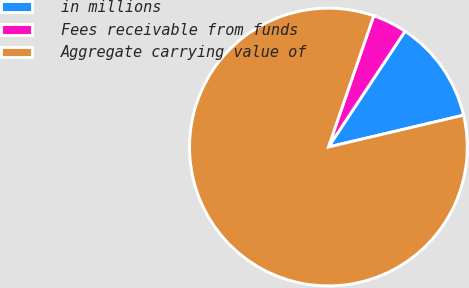Convert chart. <chart><loc_0><loc_0><loc_500><loc_500><pie_chart><fcel>in millions<fcel>Fees receivable from funds<fcel>Aggregate carrying value of<nl><fcel>12.01%<fcel>4.01%<fcel>83.97%<nl></chart> 